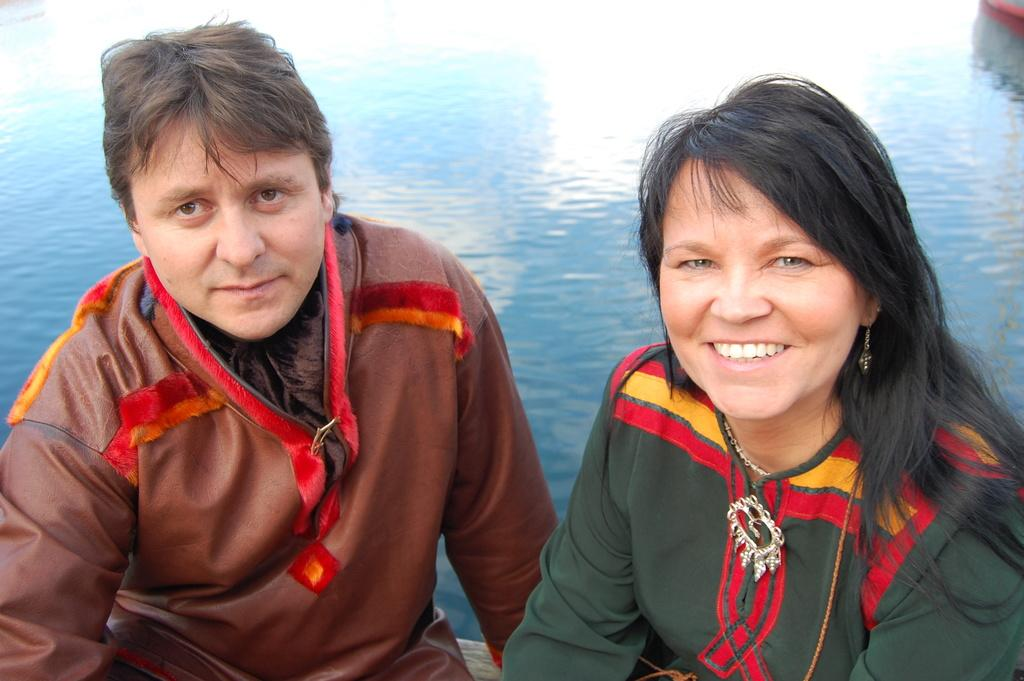Who is present in the image? There is a man and a woman in the image. What are the man and woman doing in the image? Both the man and woman are sitting. What expressions do the man and woman have in the image? The man and woman are smiling. What can be seen in the background of the image? There is water visible in the background of the image. What type of cherries are being read in the book by the man in the image? There is no book or cherries present in the image. What statement does the woman make about the cherries in the image? There are no cherries or statements about cherries in the image. 